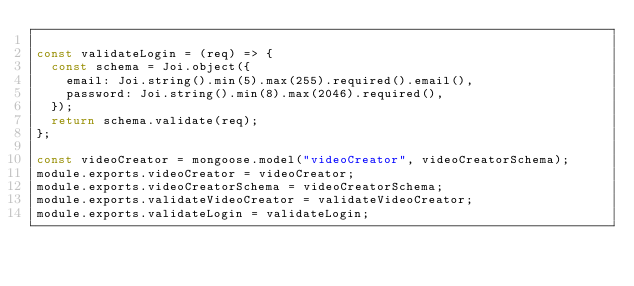Convert code to text. <code><loc_0><loc_0><loc_500><loc_500><_JavaScript_>
const validateLogin = (req) => {
  const schema = Joi.object({
    email: Joi.string().min(5).max(255).required().email(),
    password: Joi.string().min(8).max(2046).required(),
  });
  return schema.validate(req);
};

const videoCreator = mongoose.model("videoCreator", videoCreatorSchema);
module.exports.videoCreator = videoCreator;
module.exports.videoCreatorSchema = videoCreatorSchema;
module.exports.validateVideoCreator = validateVideoCreator;
module.exports.validateLogin = validateLogin;
</code> 